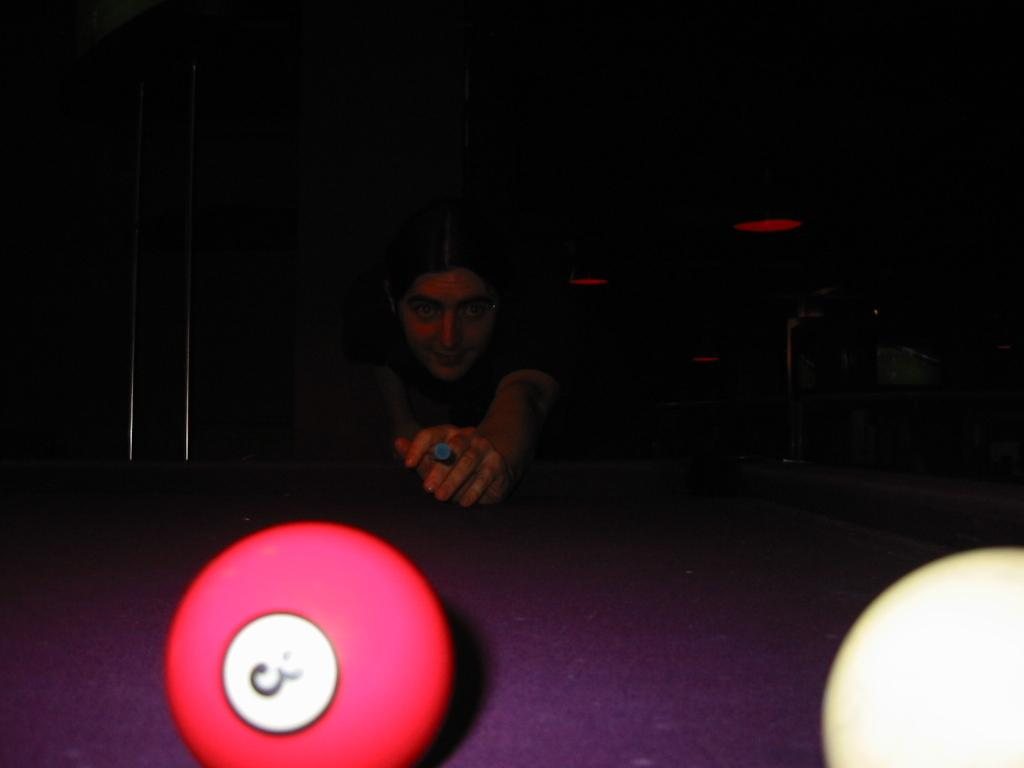What activity is the person in the image engaged in? The person in the image is playing snookers. What objects related to the game can be seen in the image? There are two snooker balls at the bottom of the image on a table. How would you describe the overall lighting in the image? The background of the image is dark. What type of skirt is the bird wearing in the image? There is no bird or skirt present in the image. 